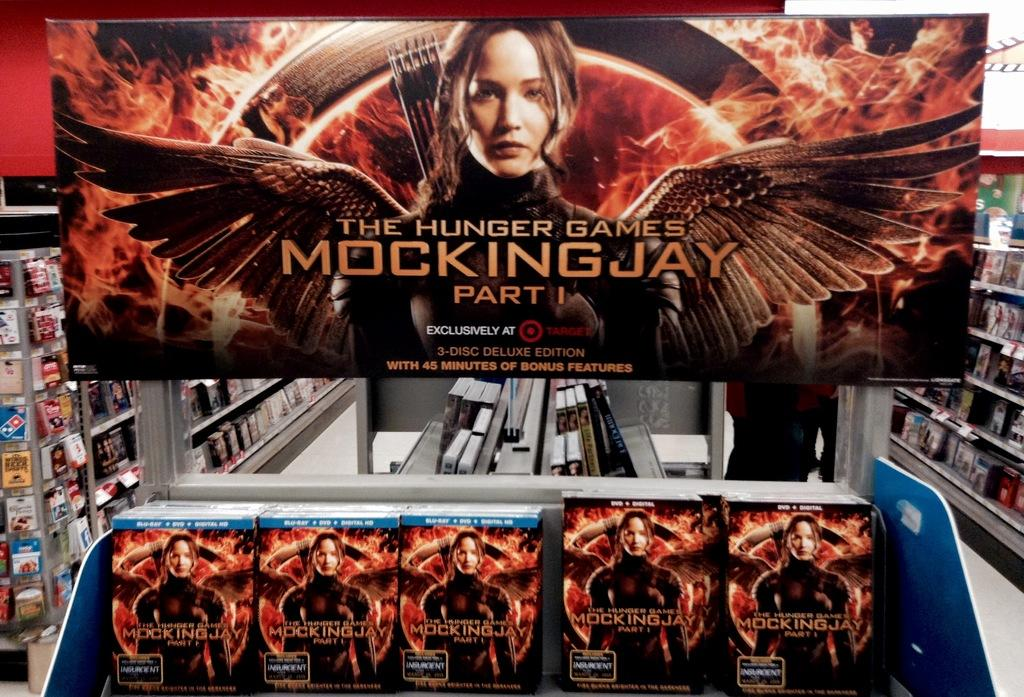<image>
Give a short and clear explanation of the subsequent image. A selection of games in a store about The Hunger games. 